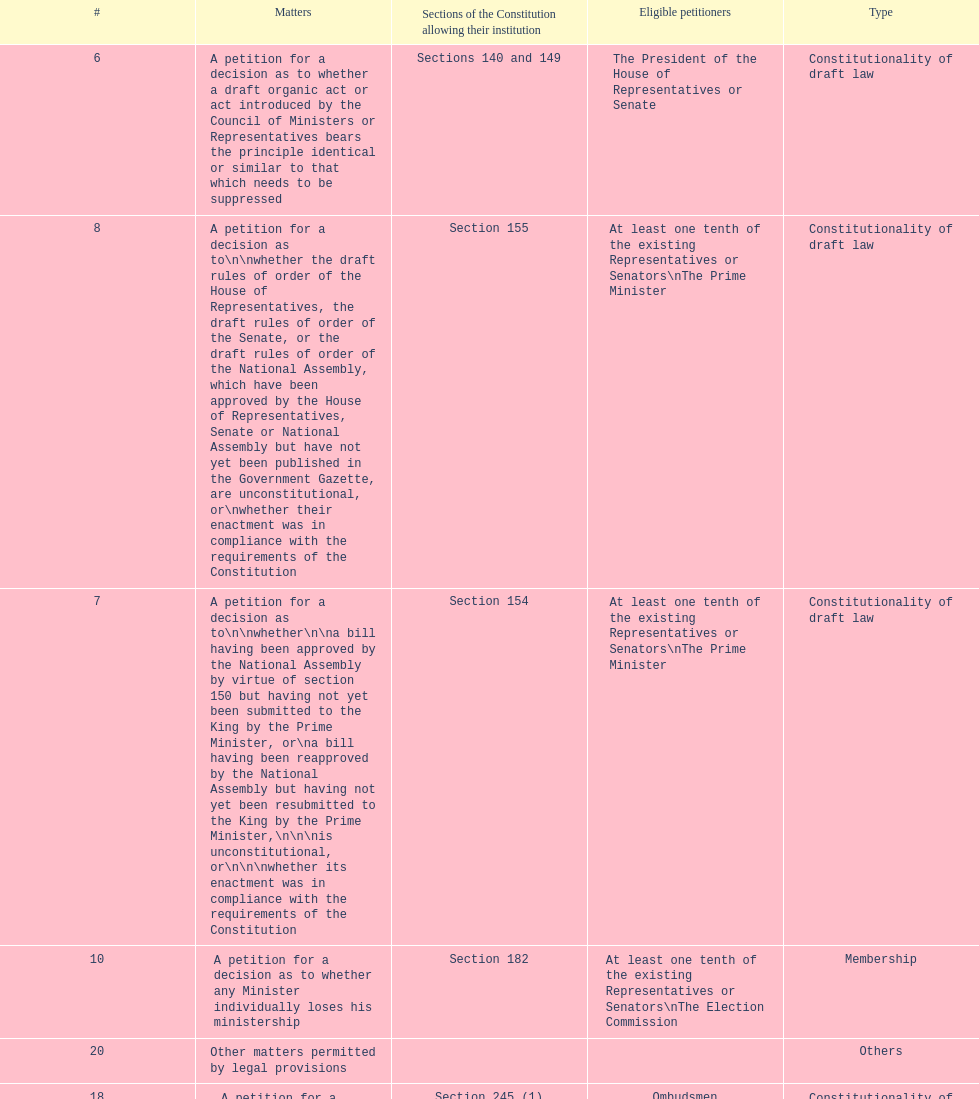How many matters have political party as their "type"? 3. 